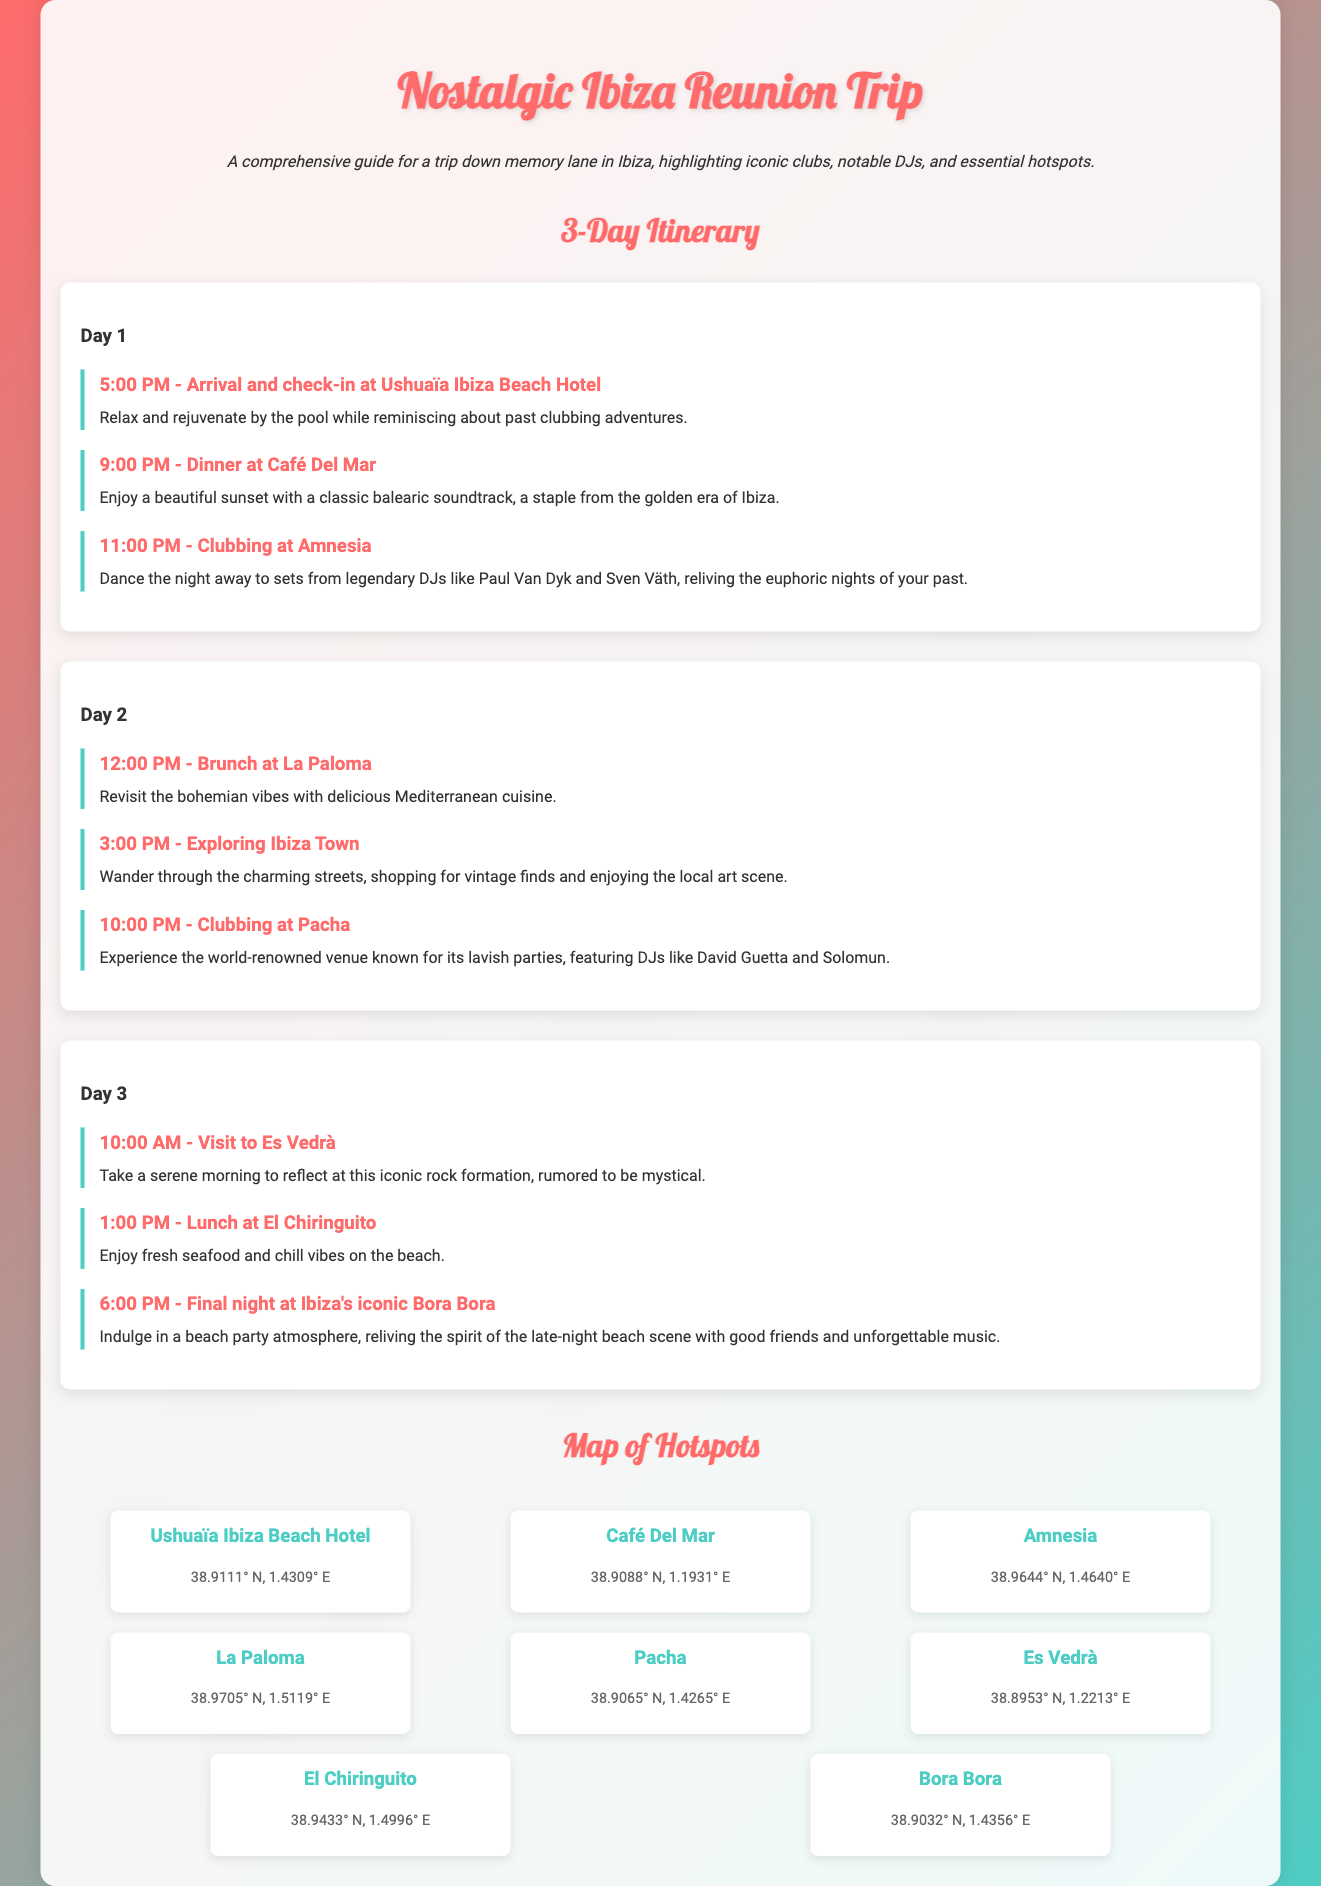What time does the first activity start on Day 1? The first activity on Day 1 is at 5:00 PM, as stated in the itinerary.
Answer: 5:00 PM Which DJ is mentioned for the club Amnesia? The document states legendary DJs like Paul Van Dyk and Sven Väth are associated with Amnesia.
Answer: Paul Van Dyk, Sven Väth Where is the Café Del Mar located? The coordinates for Café Del Mar are provided in the hotspots section of the document, which is 38.9088° N, 1.1931° E.
Answer: 38.9088° N, 1.1931° E What is the last activity mentioned in the itinerary? The last activity in the itinerary is at 6:00 PM on Day 3, featuring the final night at Bora Bora.
Answer: Final night at Bora Bora How many days does the itinerary cover? The document clearly outlines a 3-day itinerary for the trip.
Answer: 3 days Which restaurant is mentioned on Day 2 for brunch? The itinerary specifies La Paloma as the place for brunch on Day 2.
Answer: La Paloma What type of cuisine is offered at El Chiringuito? The document describes the food at El Chiringuito as fresh seafood, indicating the type of cuisine served there.
Answer: Fresh seafood What is the iconic rock formation mentioned in the itinerary? The iconic rock formation referenced during the visit on Day 3 is Es Vedrà.
Answer: Es Vedrà 